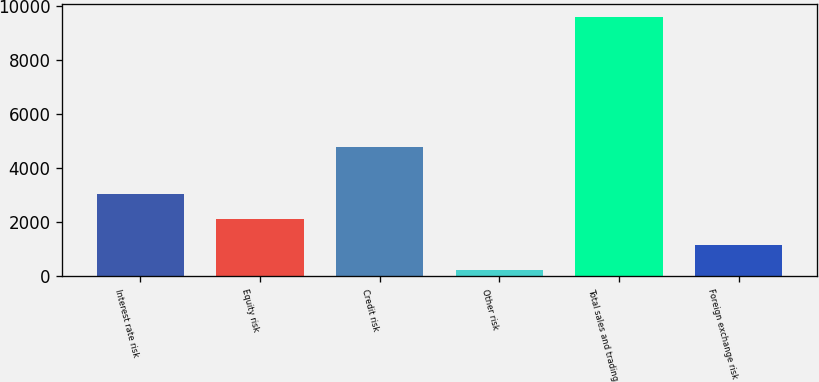<chart> <loc_0><loc_0><loc_500><loc_500><bar_chart><fcel>Interest rate risk<fcel>Equity risk<fcel>Credit risk<fcel>Other risk<fcel>Total sales and trading<fcel>Foreign exchange risk<nl><fcel>3038.4<fcel>2101.6<fcel>4791<fcel>228<fcel>9596<fcel>1164.8<nl></chart> 